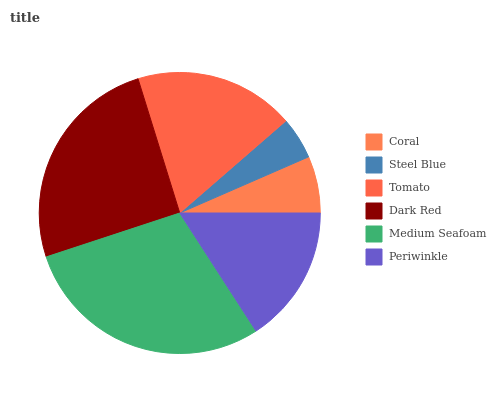Is Steel Blue the minimum?
Answer yes or no. Yes. Is Medium Seafoam the maximum?
Answer yes or no. Yes. Is Tomato the minimum?
Answer yes or no. No. Is Tomato the maximum?
Answer yes or no. No. Is Tomato greater than Steel Blue?
Answer yes or no. Yes. Is Steel Blue less than Tomato?
Answer yes or no. Yes. Is Steel Blue greater than Tomato?
Answer yes or no. No. Is Tomato less than Steel Blue?
Answer yes or no. No. Is Tomato the high median?
Answer yes or no. Yes. Is Periwinkle the low median?
Answer yes or no. Yes. Is Dark Red the high median?
Answer yes or no. No. Is Coral the low median?
Answer yes or no. No. 